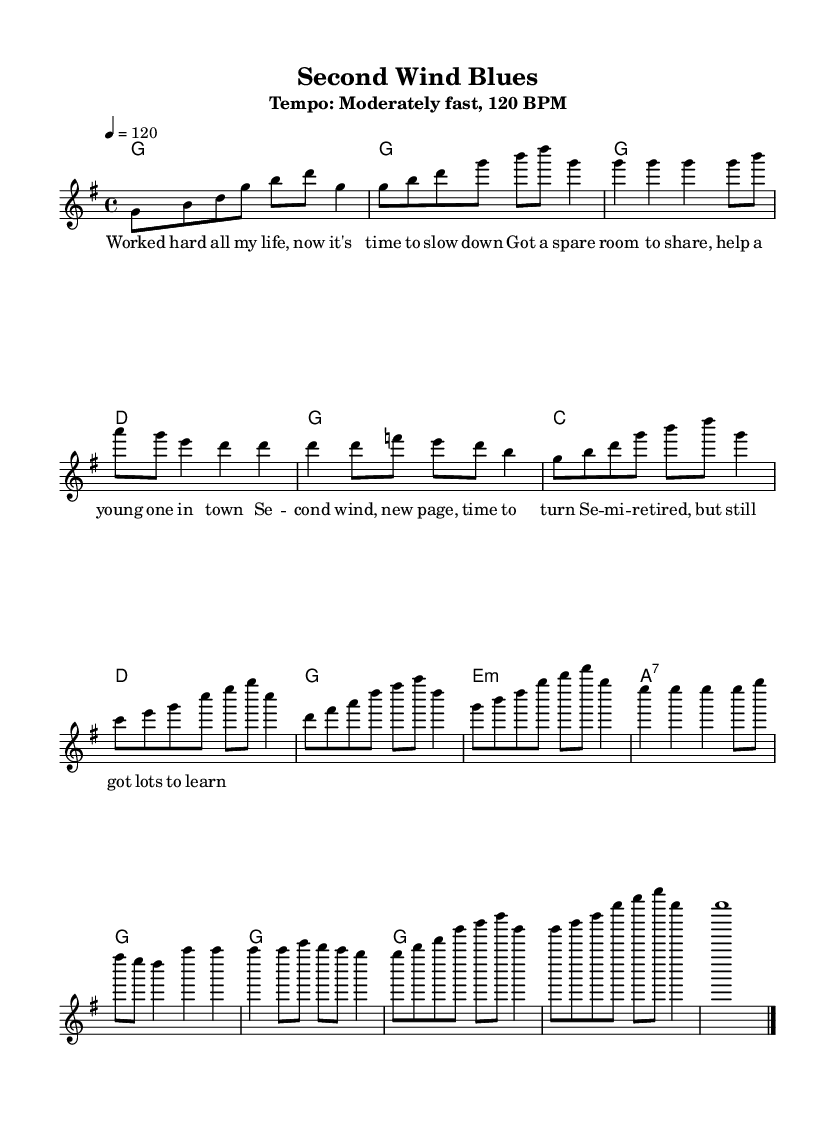What is the key signature of this music? The key signature is G major, which has one sharp (F#). It can be identified in the beginning of the music sheet where the key is specified using the key symbol.
Answer: G major What is the time signature of the piece? The time signature is 4/4, which indicates that there are four beats in each measure and a quarter note gets one beat. This is evident from the time signature written at the beginning of the music.
Answer: 4/4 What is the tempo marking for this song? The tempo marking is "Moderately fast, 120 BPM", indicating the speed of the music, which can be found in the header section of the sheet music.
Answer: 120 BPM How many chords are in the chorus section? The chorus section contains four chords: G, C, D, and G. This can be counted by looking at the chord changes under the melody in the chorus part.
Answer: Four What musical form does this piece represent? This piece represents a standard blues form, typically characterized by a repeated pattern in the verses and a distinct chorus. In this case, the verses and chorus structure aligns with classic blues forms.
Answer: Blues form What is the main theme of the lyrics? The main theme of the lyrics is about celebrating the joys of semi-retirement and embracing new beginnings. This is reflected in the lyrics that talk about slowing down and helping a young person in town.
Answer: Celebration of semi-retirement 